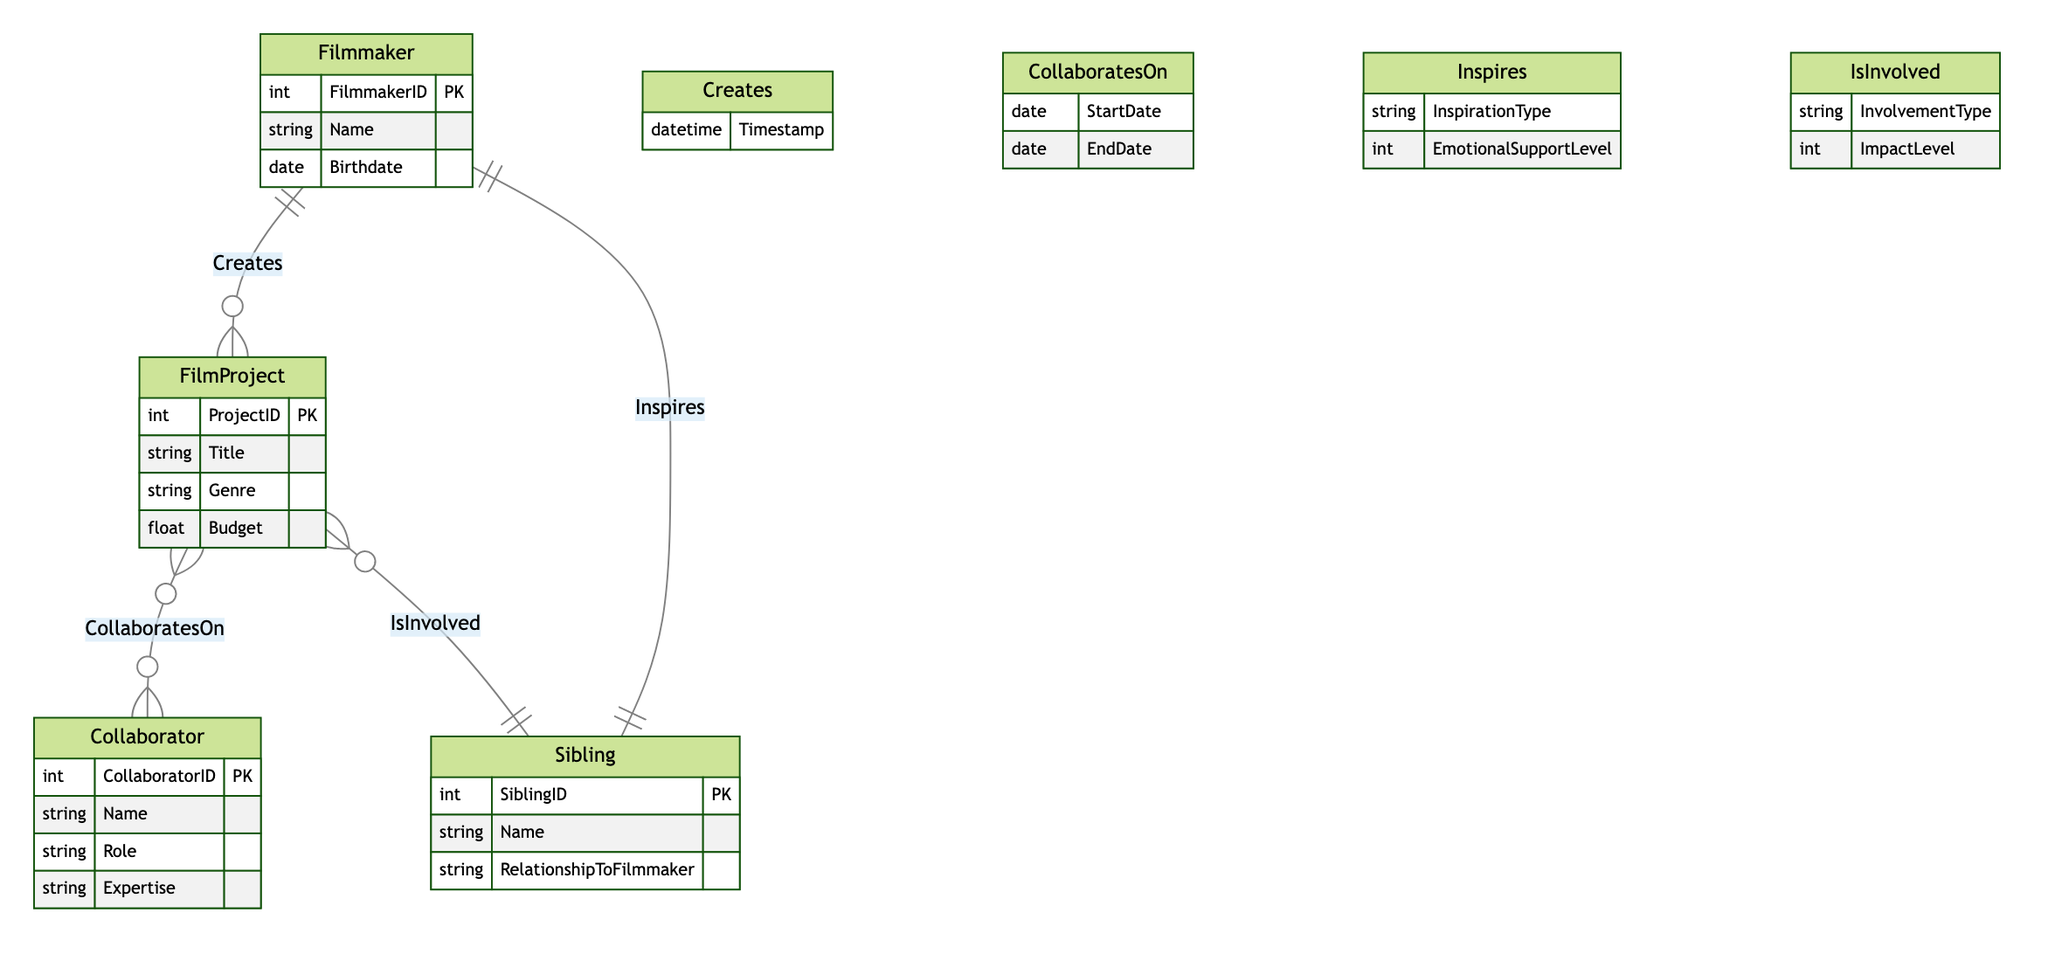What is the primary role of the Filmmaker in the diagram? The Filmmaker has the primary role of creating FilmProjects, which is indicated by the "Creates" relationship connecting them to FilmProject. The diagram specifies that each Filmmaker can create multiple FilmProjects.
Answer: Creates How many attributes does the Collaborator entity have? The Collaborator entity has four attributes: CollaboratorID, Name, Role, and Expertise. This is checked directly from the attributes listed under the Collaborator entity in the diagram.
Answer: Four What is the relationship type between Sibling and FilmProject? The relationship type between Sibling and FilmProject is "IsInvolved", which indicates that a Sibling can be involved in many FilmProjects, as indicated by the cardinality in the diagram.
Answer: IsInvolved How many FilmProjects can a Collaborator work on at once? A Collaborator can work on multiple FilmProjects simultaneously, as indicated by the cardinality showing "N" on the Collaborator side and "M" on the FilmProject side of the "CollaboratesOn" relationship.
Answer: Multiple What attribute represents emotional support in the relationship between Sibling and Filmmaker? The attribute that represents emotional support in the relationship between Sibling and Filmmaker is "EmotionalSupportLevel." This attribute is specified in the "Inspires" relationship connecting the two entities.
Answer: EmotionalSupportLevel What is the maximum number of Siblings that can inspire a single Filmmaker? The relationship "Inspires" indicates that one Sibling can inspire one Filmmaker, as shown by the cardinality indicating "1" at both ends of the relationship.
Answer: One Which entity cannot exist without a FilmProject? The Collaborator entity cannot exist without a FilmProject, as indicated by the "CollaboratesOn" relationship where Collaborator is on the "N" side, implying multiple Collaborators are associated with one FilmProject.
Answer: Collaborator What is one responsibility of a Sibling in the context of a FilmProject? One responsibility of a Sibling in the context of a FilmProject is involvement, as seen in the "IsInvolved" relationship which connects Sibling to FilmProject, indicating they can participate in the projects.
Answer: Involvement 